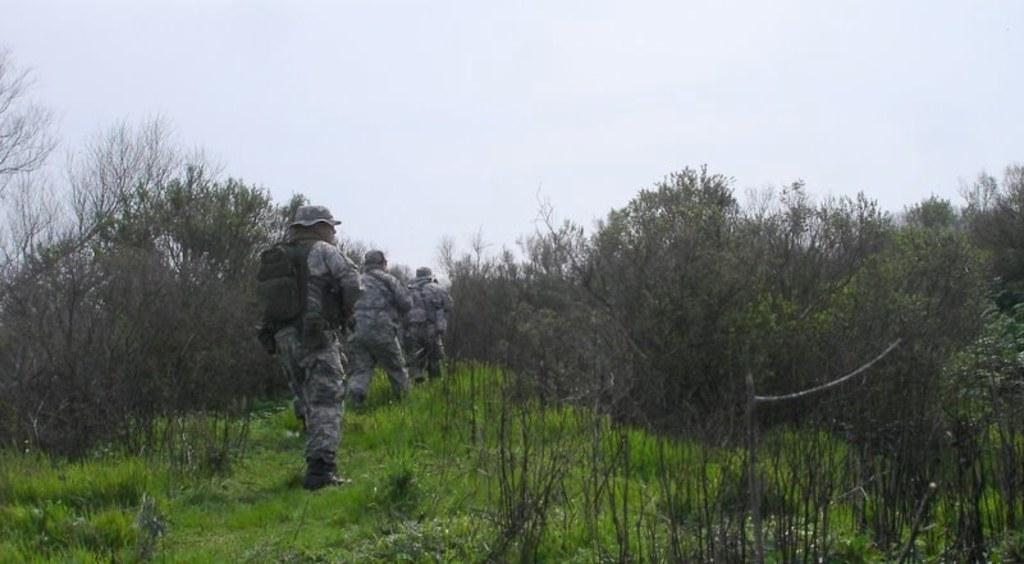What type of surface can be seen in the image? There is ground visible in the image. What is growing on the ground in the image? There is grass on the ground in the image. What type of vegetation is present in the image? There are trees in the image. What are the persons in the image wearing? The persons in the image are wearing uniforms. What can be seen in the background of the image? The sky is visible in the background of the image. What nation is being represented by the persons wearing uniforms in the image? The provided facts do not mention any specific nation or uniform, so it cannot be determined from the image. How does the thought process of the trees in the image work? Trees do not have a thought process, as they are plants and not sentient beings. 